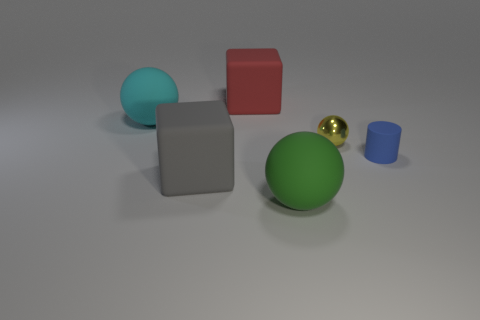There is a green rubber object; how many large matte spheres are left of it?
Ensure brevity in your answer.  1. How many matte cubes are both in front of the large red matte thing and behind the matte cylinder?
Offer a very short reply. 0. There is a large cyan object that is the same material as the small blue object; what is its shape?
Your answer should be compact. Sphere. There is a rubber thing behind the big cyan object; is it the same size as the matte sphere that is behind the tiny rubber cylinder?
Offer a terse response. Yes. What color is the large cube that is behind the big cyan rubber object?
Make the answer very short. Red. There is a block that is behind the big matte ball that is behind the small shiny object; what is its material?
Make the answer very short. Rubber. What shape is the metal thing?
Provide a succinct answer. Sphere. What material is the cyan object that is the same shape as the big green matte object?
Give a very brief answer. Rubber. How many gray cubes are the same size as the red cube?
Offer a very short reply. 1. There is a rubber cube in front of the yellow metal ball; is there a large thing in front of it?
Make the answer very short. Yes. 